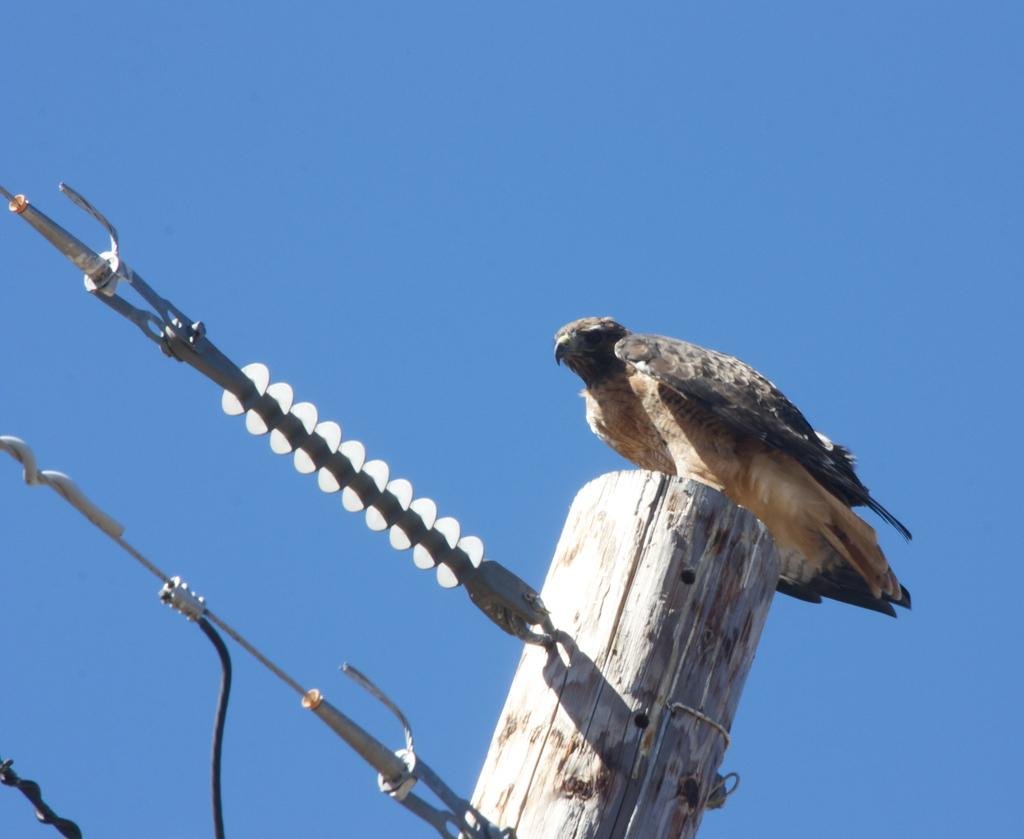What is on the wooden pole in the image? There is a bird on a wooden pole in the image. What else can be seen in the image besides the bird on the pole? There are wires visible in the image. What is the color of the sky in the image? The sky is blue in color. What type of berry can be seen growing on the wooden pole in the image? There is no berry growing on the wooden pole in the image; it features a bird on the pole and wires. What is the texture of the bird's feathers in the image? The texture of the bird's feathers cannot be determined from the image alone, as the image resolution may not be high enough to discern such details. 